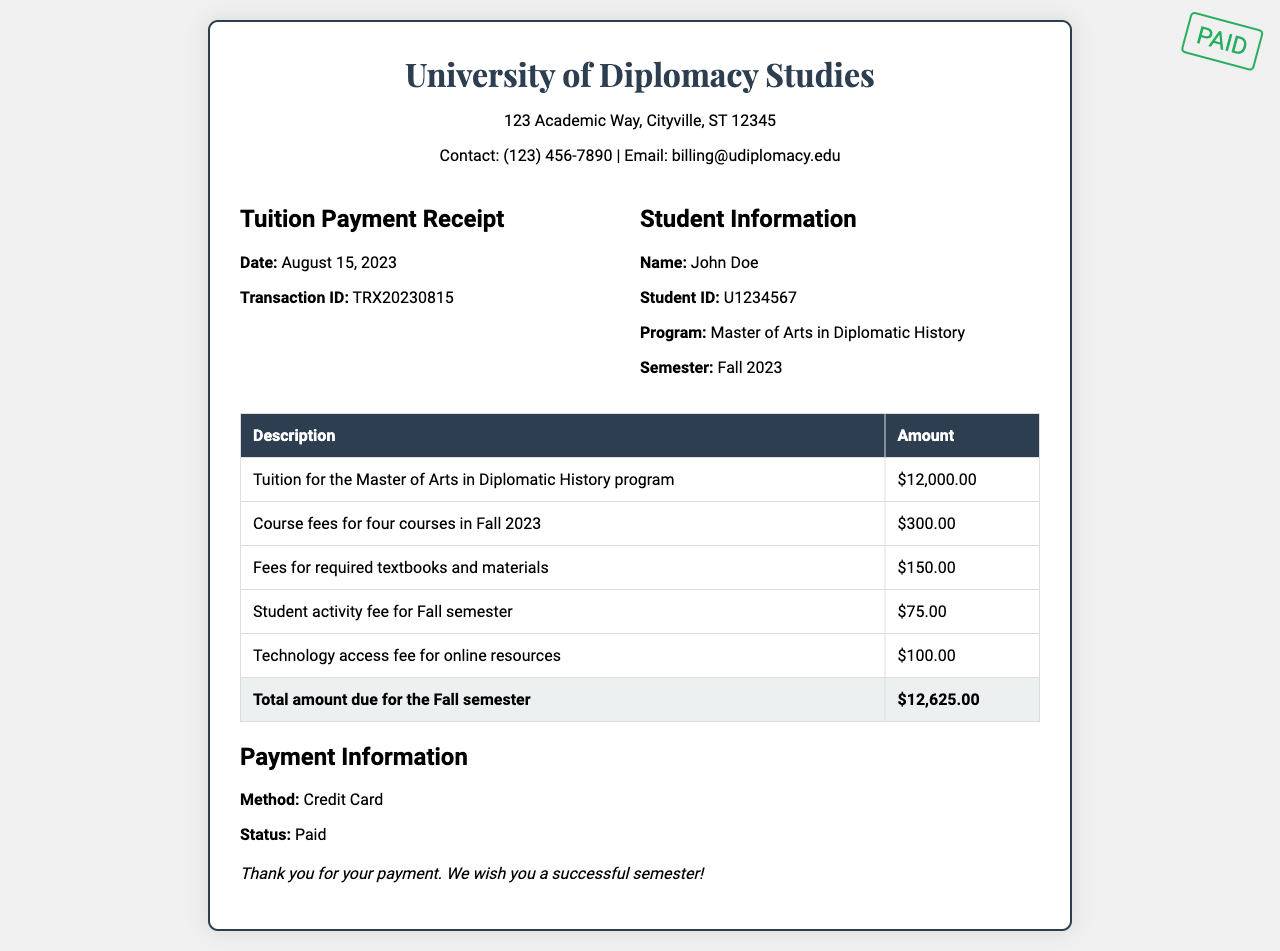what is the name of the institution? The institution is named University of Diplomacy Studies according to the header of the receipt.
Answer: University of Diplomacy Studies what is the date of the receipt? The date is clearly stated in the receipt, indicating when the payment was made.
Answer: August 15, 2023 what is the total amount due for the Fall semester? The total amount due is presented at the bottom of the table summarizing all charges.
Answer: $12,625.00 how many courses are covered by the course fees? The document specifies that the course fees are for four courses, as mentioned in the breakdown of charges.
Answer: four what is the student's program? The program listed under student information indicates the area of study for the student.
Answer: Master of Arts in Diplomatic History what is the amount for the technology access fee? The technology access fee is itemized in the breakdown of charges on the receipt.
Answer: $100.00 what was the method of payment? The method of payment is mentioned in the payment information section of the receipt.
Answer: Credit Card what is the student ID of John Doe? The student ID is explicitly mentioned in the student information section of the receipt.
Answer: U1234567 what type of fee is the amount of $75 associated with? The fee of $75 is identified as the student activity fee for the Fall semester according to the detailed list.
Answer: student activity fee 